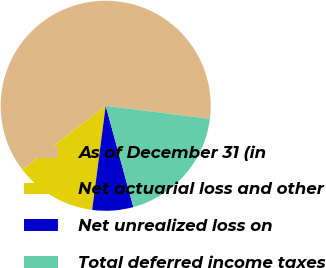Convert chart to OTSL. <chart><loc_0><loc_0><loc_500><loc_500><pie_chart><fcel>As of December 31 (in<fcel>Net actuarial loss and other<fcel>Net unrealized loss on<fcel>Total deferred income taxes<nl><fcel>62.4%<fcel>12.53%<fcel>6.3%<fcel>18.77%<nl></chart> 